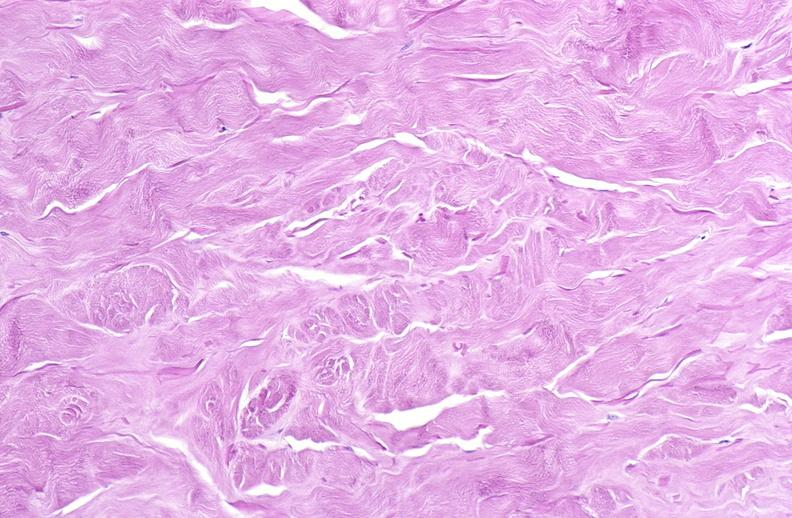where is this?
Answer the question using a single word or phrase. Skin 